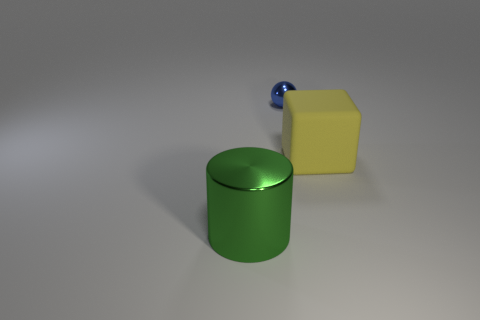Subtract all blocks. How many objects are left? 2 Add 2 green cylinders. How many objects exist? 5 Subtract all tiny blue objects. Subtract all big metallic objects. How many objects are left? 1 Add 2 green metallic cylinders. How many green metallic cylinders are left? 3 Add 3 gray matte spheres. How many gray matte spheres exist? 3 Subtract 1 blue spheres. How many objects are left? 2 